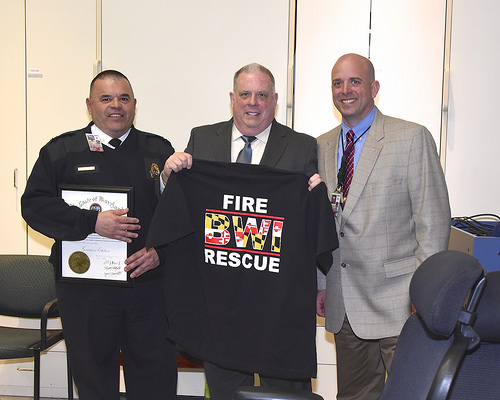<image>
Can you confirm if the shirt is to the left of the man? Yes. From this viewpoint, the shirt is positioned to the left side relative to the man. 